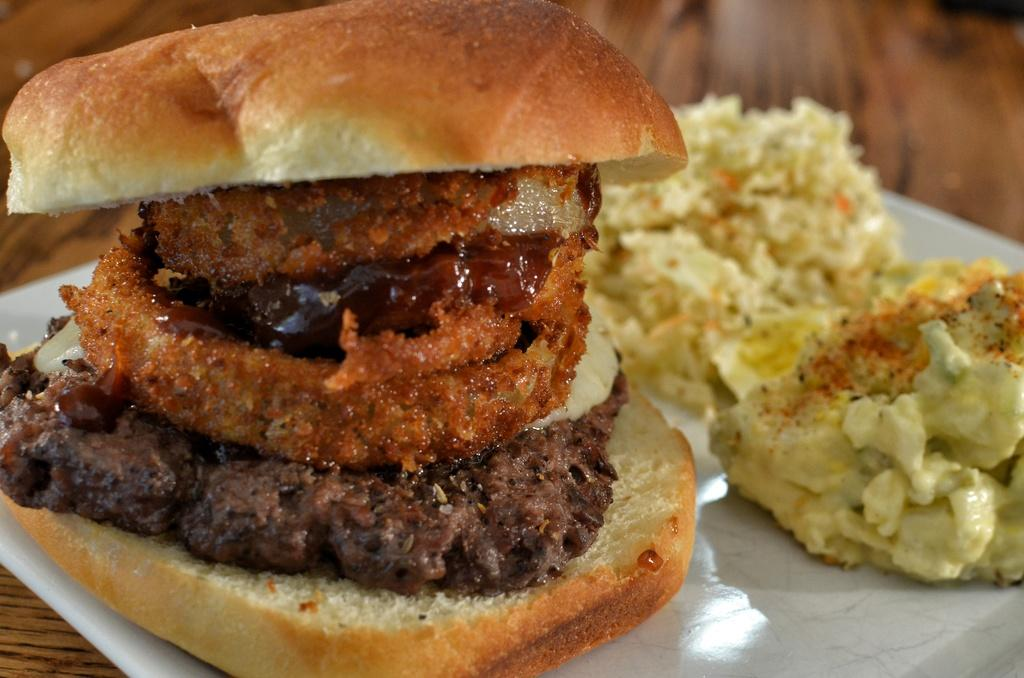What object is present on the table in the image? There is a plate on the table in the image. What is the purpose of the plate in the image? The plate is used to hold food. What type of food can be seen on the plate? The facts do not specify the type of food on the plate. What color is the curtain hanging behind the plate in the image? There is no curtain present in the image. How many snails can be seen crawling on the plate in the image? There are no snails present in the image. 